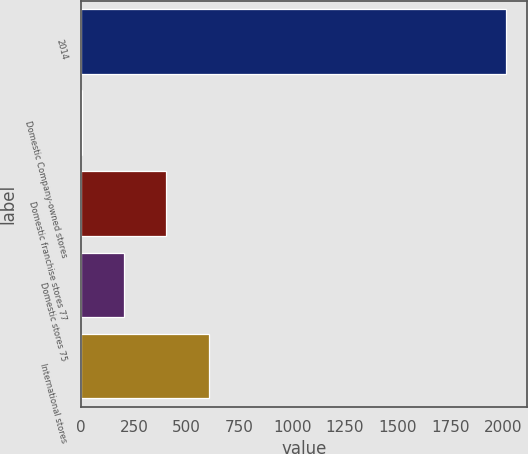<chart> <loc_0><loc_0><loc_500><loc_500><bar_chart><fcel>2014<fcel>Domestic Company-owned stores<fcel>Domestic franchise stores 77<fcel>Domestic stores 75<fcel>International stores<nl><fcel>2012<fcel>1.3<fcel>403.44<fcel>202.37<fcel>604.51<nl></chart> 